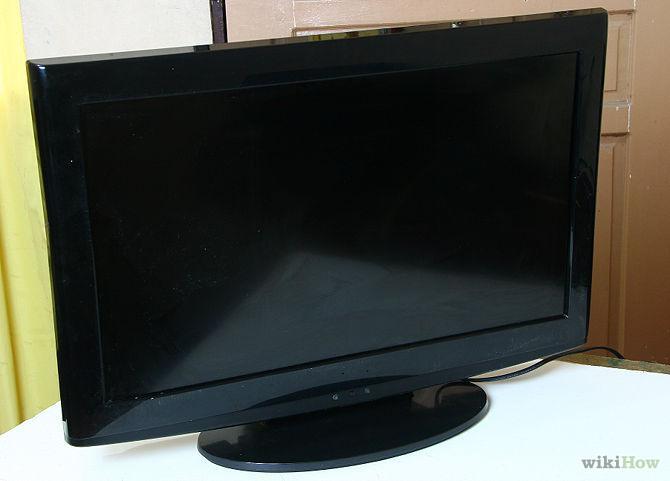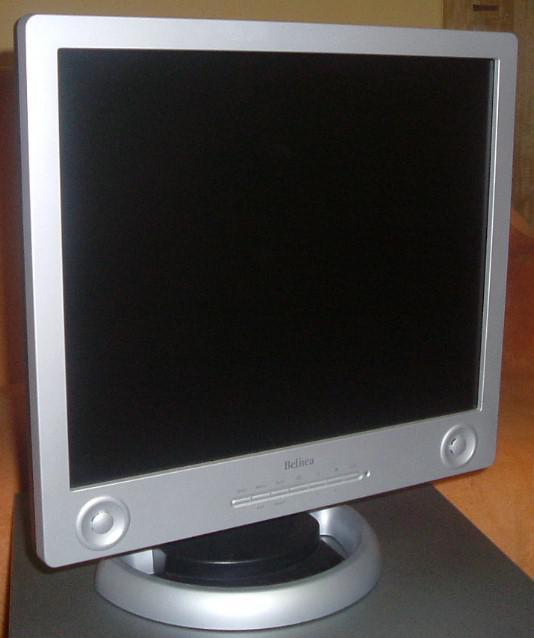The first image is the image on the left, the second image is the image on the right. Assess this claim about the two images: "Each image contains exactly one upright TV on a stand, and one image depicts a TV head-on, while the other image depicts a TV at an angle.". Correct or not? Answer yes or no. No. The first image is the image on the left, the second image is the image on the right. Given the left and right images, does the statement "The left and right image contains the same number of computer monitors with one being silver." hold true? Answer yes or no. Yes. 